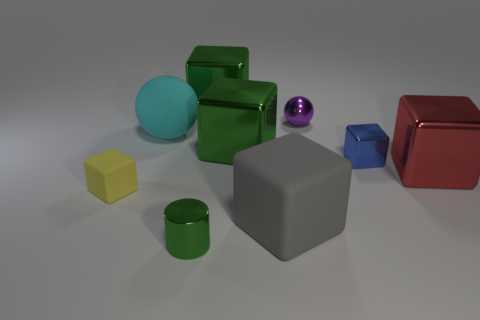Subtract all matte blocks. How many blocks are left? 4 Subtract 4 cubes. How many cubes are left? 2 Subtract all brown balls. How many green cubes are left? 2 Subtract all purple balls. How many balls are left? 1 Add 1 big rubber balls. How many big rubber balls are left? 2 Add 6 green cylinders. How many green cylinders exist? 7 Subtract 1 cyan spheres. How many objects are left? 8 Subtract all spheres. How many objects are left? 7 Subtract all red cylinders. Subtract all cyan blocks. How many cylinders are left? 1 Subtract all yellow cubes. Subtract all tiny purple spheres. How many objects are left? 7 